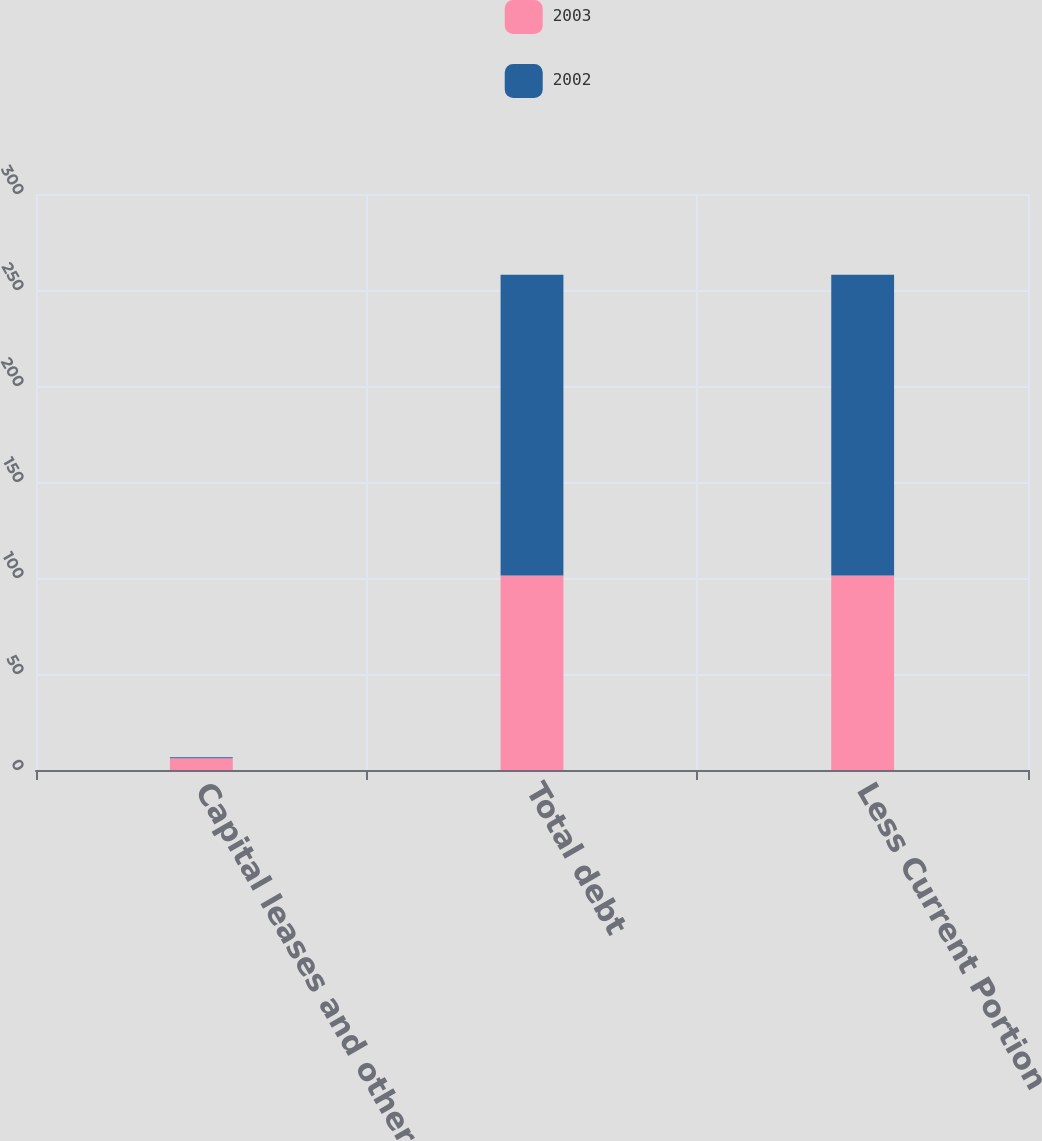Convert chart to OTSL. <chart><loc_0><loc_0><loc_500><loc_500><stacked_bar_chart><ecel><fcel>Capital leases and other<fcel>Total debt<fcel>Less Current Portion<nl><fcel>2003<fcel>6.1<fcel>101.3<fcel>101.3<nl><fcel>2002<fcel>0.5<fcel>156.7<fcel>156.7<nl></chart> 